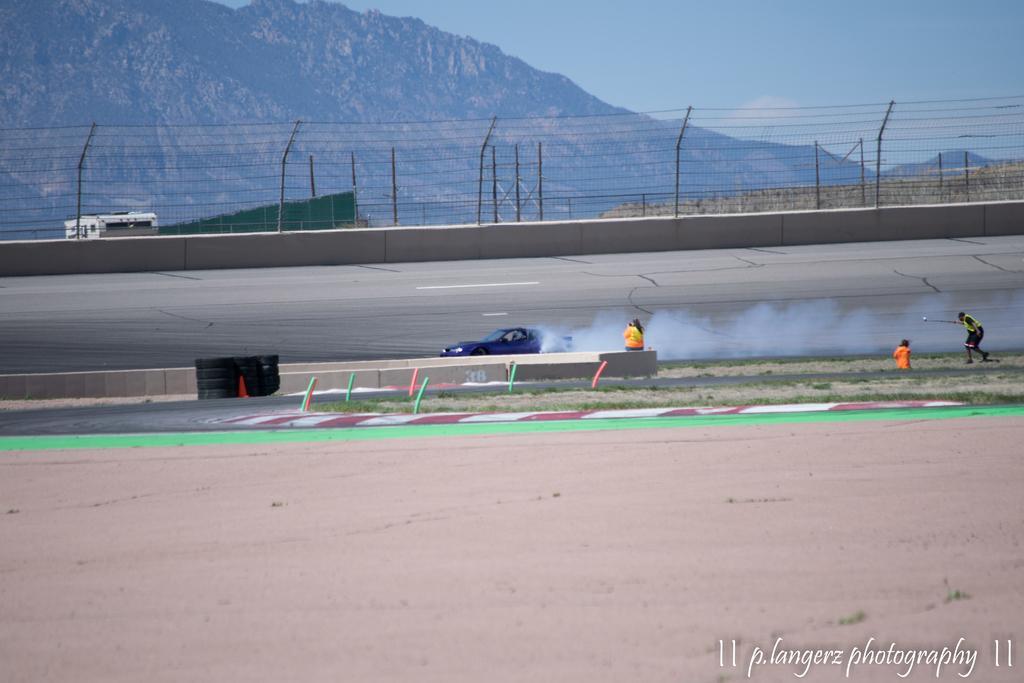Can you describe this image briefly? In this image we can see a mountain. There is a fencing in the image. There are few people in the image. A person is driving a car on the road. There are few objects in the image. There is a group of tires in the image. There is a sky in the image. There is a vehicle in the image. There is some text at the bottom of the image. 